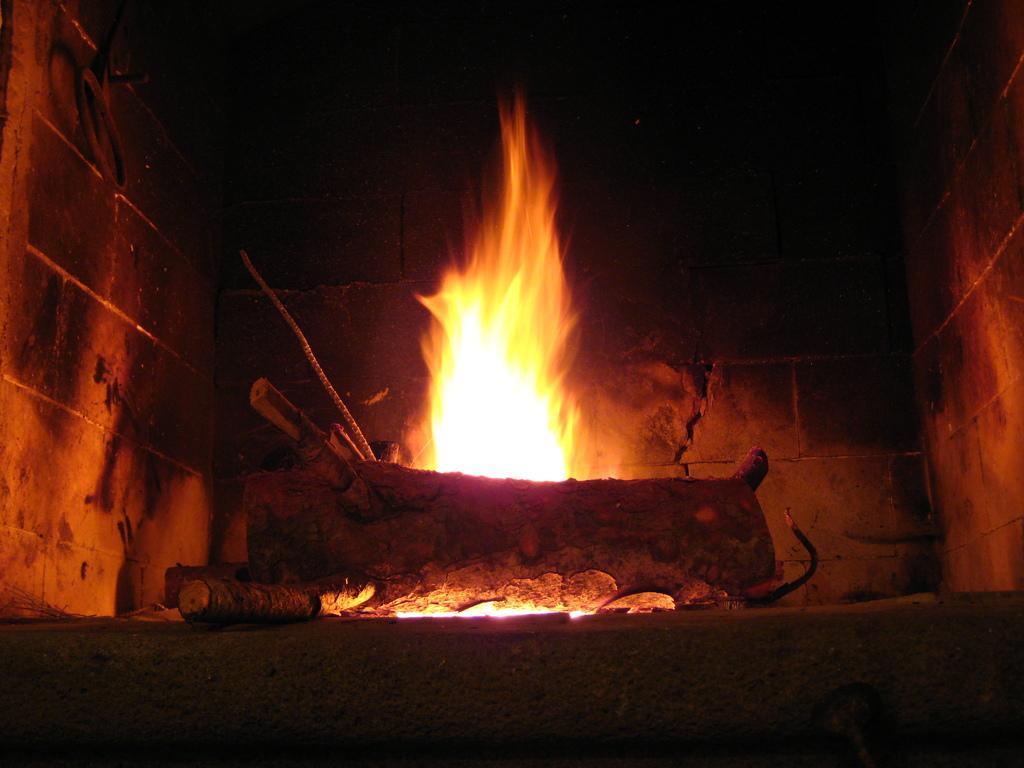How would you summarize this image in a sentence or two? In the center of the image, we can see a fireplace and there are logs. In the background, there is a wall. 